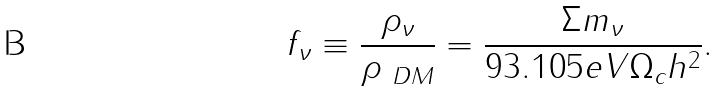<formula> <loc_0><loc_0><loc_500><loc_500>f _ { \nu } \equiv \frac { \rho _ { \nu } } { \rho _ { \ D M } } = \frac { \Sigma m _ { \nu } } { 9 3 . 1 0 5 e V \Omega _ { c } h ^ { 2 } } .</formula> 